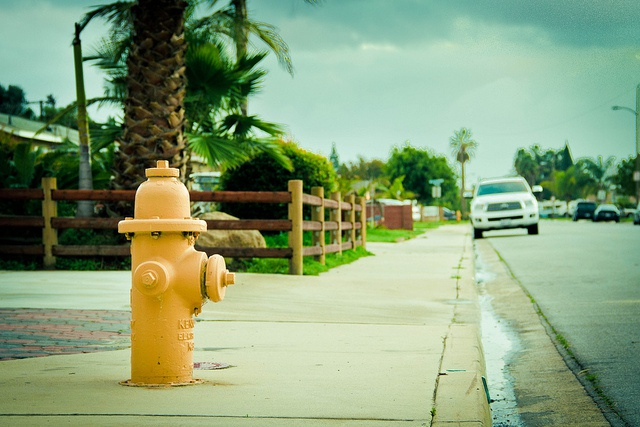Describe the objects in this image and their specific colors. I can see fire hydrant in turquoise, orange, and khaki tones, car in turquoise, ivory, lightgreen, black, and lightblue tones, car in turquoise, black, and teal tones, car in turquoise, tan, beige, darkgray, and lightblue tones, and car in turquoise, darkgreen, black, and teal tones in this image. 